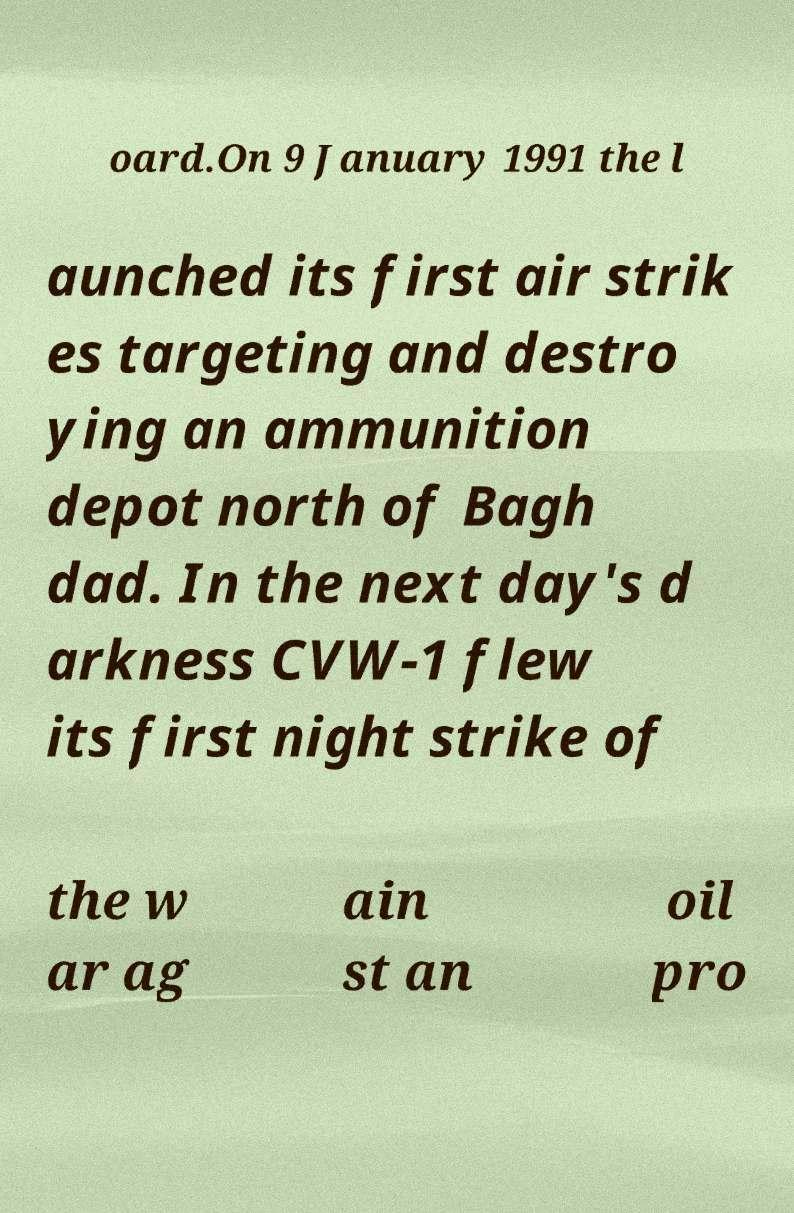Please identify and transcribe the text found in this image. oard.On 9 January 1991 the l aunched its first air strik es targeting and destro ying an ammunition depot north of Bagh dad. In the next day's d arkness CVW-1 flew its first night strike of the w ar ag ain st an oil pro 